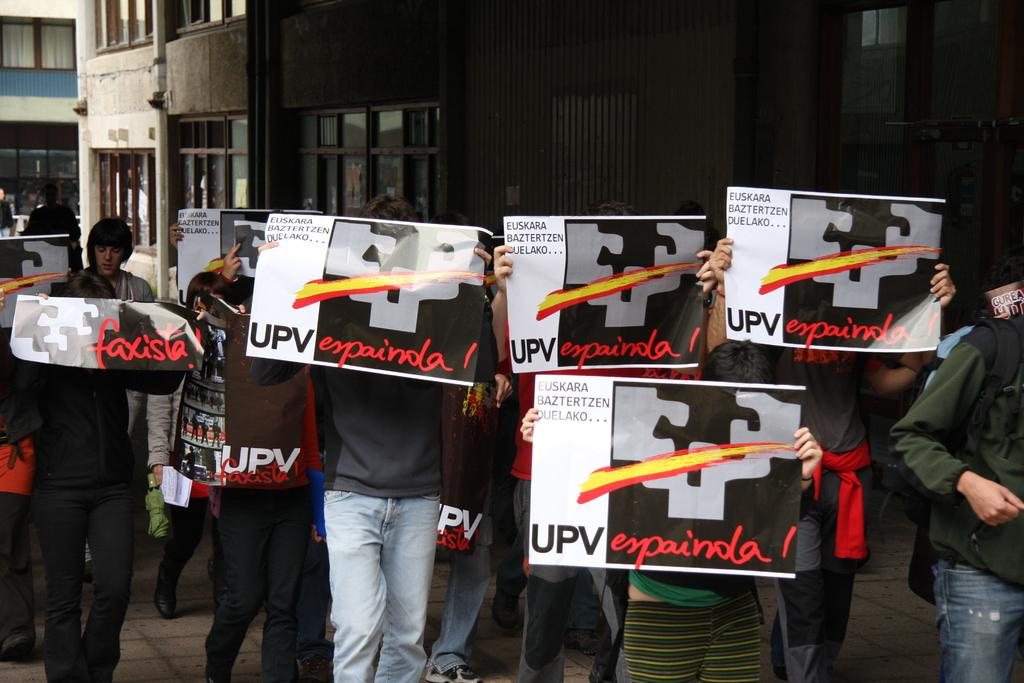What are the persons in the image holding? The persons in the image are holding papers. What can be seen in the background of the image? There are buildings, windows, and a pole visible in the background of the image. How many grapes can be seen on the pole in the image? There are no grapes present in the image, and the pole does not have any grapes attached to it. 